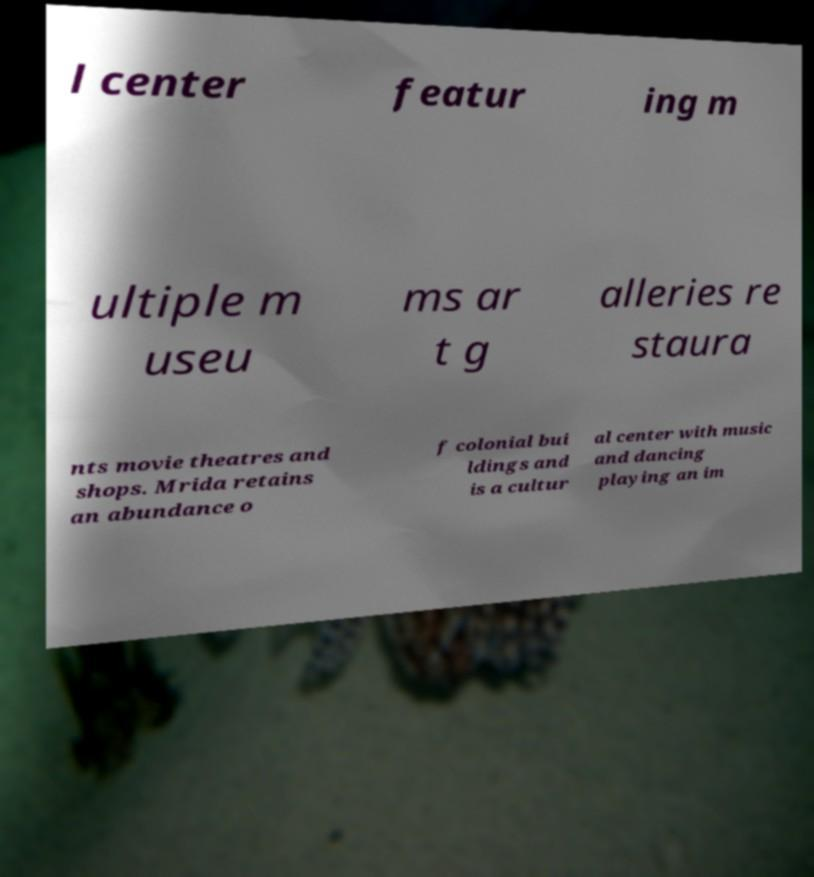Can you accurately transcribe the text from the provided image for me? l center featur ing m ultiple m useu ms ar t g alleries re staura nts movie theatres and shops. Mrida retains an abundance o f colonial bui ldings and is a cultur al center with music and dancing playing an im 